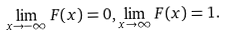Convert formula to latex. <formula><loc_0><loc_0><loc_500><loc_500>\lim _ { x \to - \infty } F ( x ) = 0 , \lim _ { x \to \infty } F ( x ) = 1 .</formula> 